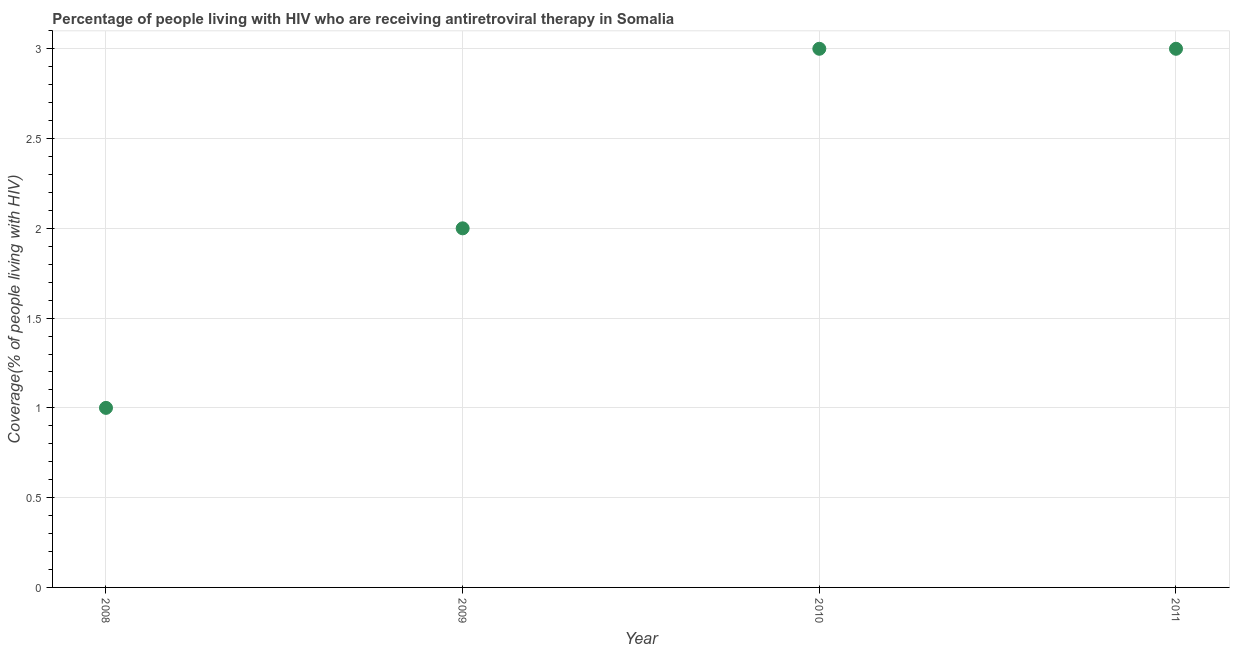What is the antiretroviral therapy coverage in 2011?
Your response must be concise. 3. Across all years, what is the maximum antiretroviral therapy coverage?
Give a very brief answer. 3. Across all years, what is the minimum antiretroviral therapy coverage?
Your response must be concise. 1. In which year was the antiretroviral therapy coverage minimum?
Your response must be concise. 2008. What is the sum of the antiretroviral therapy coverage?
Ensure brevity in your answer.  9. What is the difference between the antiretroviral therapy coverage in 2008 and 2010?
Your answer should be very brief. -2. What is the average antiretroviral therapy coverage per year?
Your answer should be very brief. 2.25. What is the median antiretroviral therapy coverage?
Your response must be concise. 2.5. In how many years, is the antiretroviral therapy coverage greater than 0.30000000000000004 %?
Ensure brevity in your answer.  4. Is the antiretroviral therapy coverage in 2010 less than that in 2011?
Your answer should be very brief. No. Is the sum of the antiretroviral therapy coverage in 2008 and 2010 greater than the maximum antiretroviral therapy coverage across all years?
Provide a short and direct response. Yes. What is the difference between the highest and the lowest antiretroviral therapy coverage?
Keep it short and to the point. 2. In how many years, is the antiretroviral therapy coverage greater than the average antiretroviral therapy coverage taken over all years?
Ensure brevity in your answer.  2. Does the antiretroviral therapy coverage monotonically increase over the years?
Keep it short and to the point. No. What is the difference between two consecutive major ticks on the Y-axis?
Your answer should be very brief. 0.5. Are the values on the major ticks of Y-axis written in scientific E-notation?
Provide a succinct answer. No. Does the graph contain any zero values?
Offer a terse response. No. What is the title of the graph?
Give a very brief answer. Percentage of people living with HIV who are receiving antiretroviral therapy in Somalia. What is the label or title of the X-axis?
Your answer should be very brief. Year. What is the label or title of the Y-axis?
Your response must be concise. Coverage(% of people living with HIV). What is the Coverage(% of people living with HIV) in 2008?
Give a very brief answer. 1. What is the difference between the Coverage(% of people living with HIV) in 2009 and 2010?
Provide a succinct answer. -1. What is the ratio of the Coverage(% of people living with HIV) in 2008 to that in 2010?
Keep it short and to the point. 0.33. What is the ratio of the Coverage(% of people living with HIV) in 2008 to that in 2011?
Make the answer very short. 0.33. What is the ratio of the Coverage(% of people living with HIV) in 2009 to that in 2010?
Offer a very short reply. 0.67. What is the ratio of the Coverage(% of people living with HIV) in 2009 to that in 2011?
Give a very brief answer. 0.67. What is the ratio of the Coverage(% of people living with HIV) in 2010 to that in 2011?
Give a very brief answer. 1. 